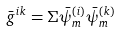<formula> <loc_0><loc_0><loc_500><loc_500>\bar { g } ^ { i k } = \Sigma \bar { \psi } _ { m } ^ { ( i ) } \bar { \psi } _ { m } ^ { ( k ) }</formula> 